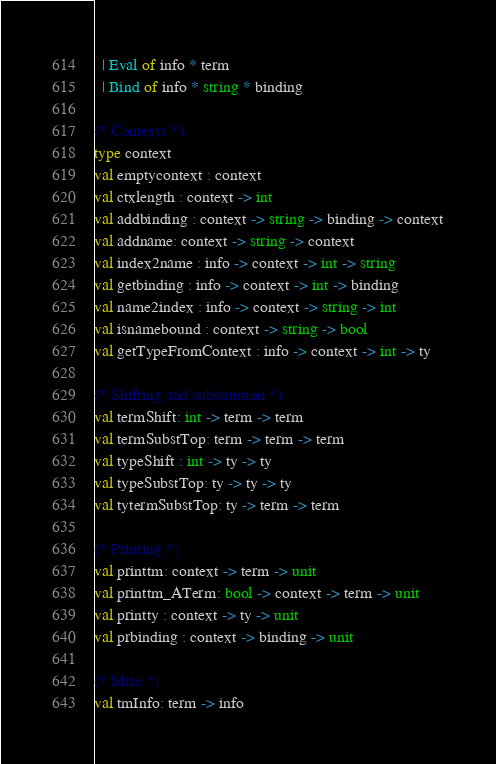<code> <loc_0><loc_0><loc_500><loc_500><_OCaml_>  | Eval of info * term
  | Bind of info * string * binding

(* Contexts *)
type context
val emptycontext : context 
val ctxlength : context -> int
val addbinding : context -> string -> binding -> context
val addname: context -> string -> context
val index2name : info -> context -> int -> string
val getbinding : info -> context -> int -> binding
val name2index : info -> context -> string -> int
val isnamebound : context -> string -> bool
val getTypeFromContext : info -> context -> int -> ty

(* Shifting and substitution *)
val termShift: int -> term -> term
val termSubstTop: term -> term -> term
val typeShift : int -> ty -> ty
val typeSubstTop: ty -> ty -> ty
val tytermSubstTop: ty -> term -> term

(* Printing *)
val printtm: context -> term -> unit
val printtm_ATerm: bool -> context -> term -> unit
val printty : context -> ty -> unit
val prbinding : context -> binding -> unit

(* Misc *)
val tmInfo: term -> info

</code> 